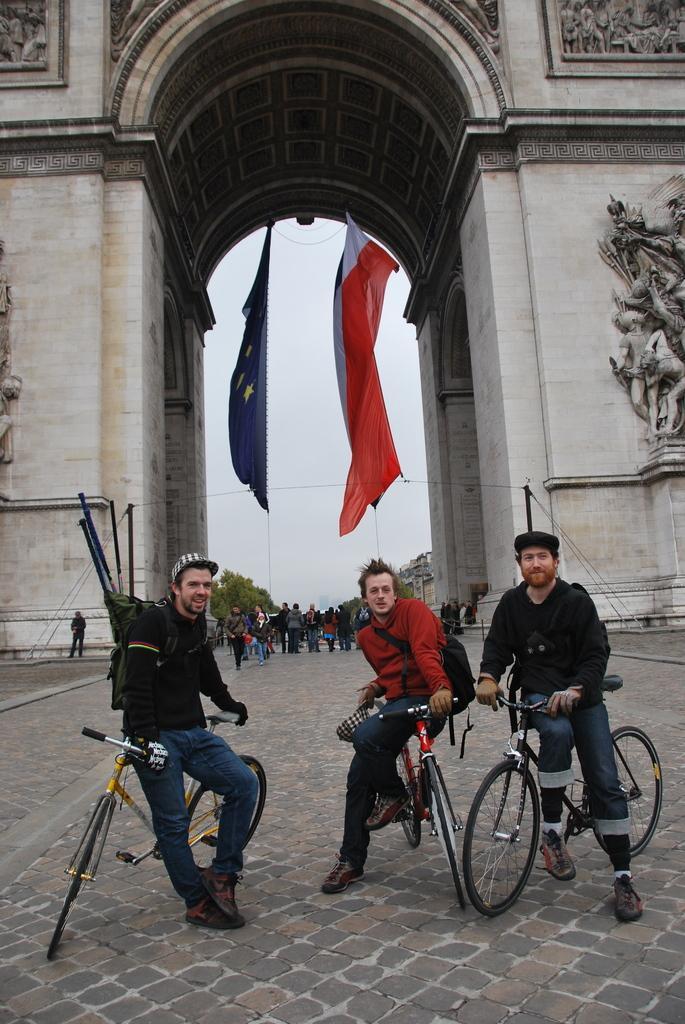Describe this image in one or two sentences. In the picture we can see three men, standing on the cycles, one man is wearing a bag with sticks and other two persons are also wearing a bags, in the background we can see a historical building gate from that we can see two flags, which is orange and white and one is blue with stars, and we can also see the sky, trees and some people. 